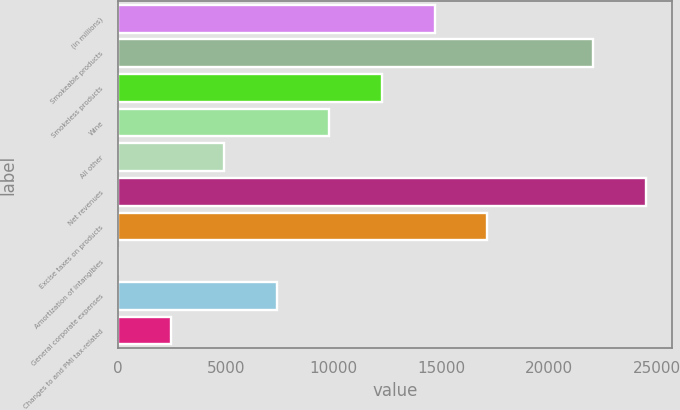Convert chart to OTSL. <chart><loc_0><loc_0><loc_500><loc_500><bar_chart><fcel>(in millions)<fcel>Smokeable products<fcel>Smokeless products<fcel>Wine<fcel>All other<fcel>Net revenues<fcel>Excise taxes on products<fcel>Amortization of intangibles<fcel>General corporate expenses<fcel>Changes to and PMI tax-related<nl><fcel>14687.6<fcel>22021.4<fcel>12243<fcel>9798.4<fcel>4909.2<fcel>24466<fcel>17132.2<fcel>20<fcel>7353.8<fcel>2464.6<nl></chart> 